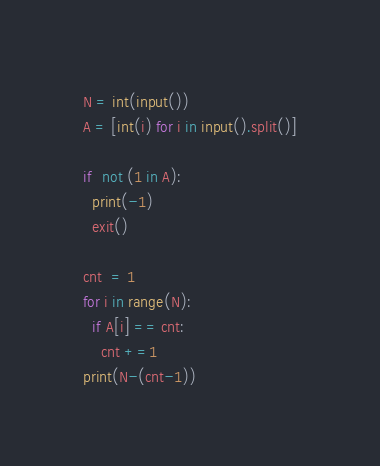<code> <loc_0><loc_0><loc_500><loc_500><_Python_>N = int(input())
A = [int(i) for i in input().split()]

if  not (1 in A):
  print(-1)
  exit()
  
cnt  = 1
for i in range(N):
  if A[i] == cnt:
    cnt +=1
print(N-(cnt-1))</code> 